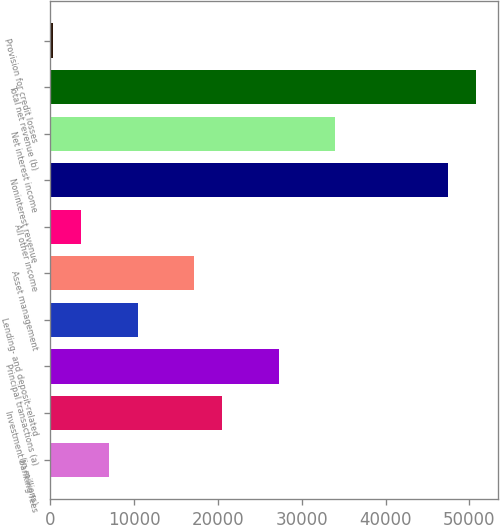Convert chart. <chart><loc_0><loc_0><loc_500><loc_500><bar_chart><fcel>(in millions)<fcel>Investment banking fees<fcel>Principal transactions (a)<fcel>Lending- and deposit-related<fcel>Asset management<fcel>All other income<fcel>Noninterest revenue<fcel>Net interest income<fcel>Total net revenue (b)<fcel>Provision for credit losses<nl><fcel>7024.8<fcel>20504.4<fcel>27244.2<fcel>10394.7<fcel>17134.5<fcel>3654.9<fcel>47463.6<fcel>33984<fcel>50833.5<fcel>285<nl></chart> 